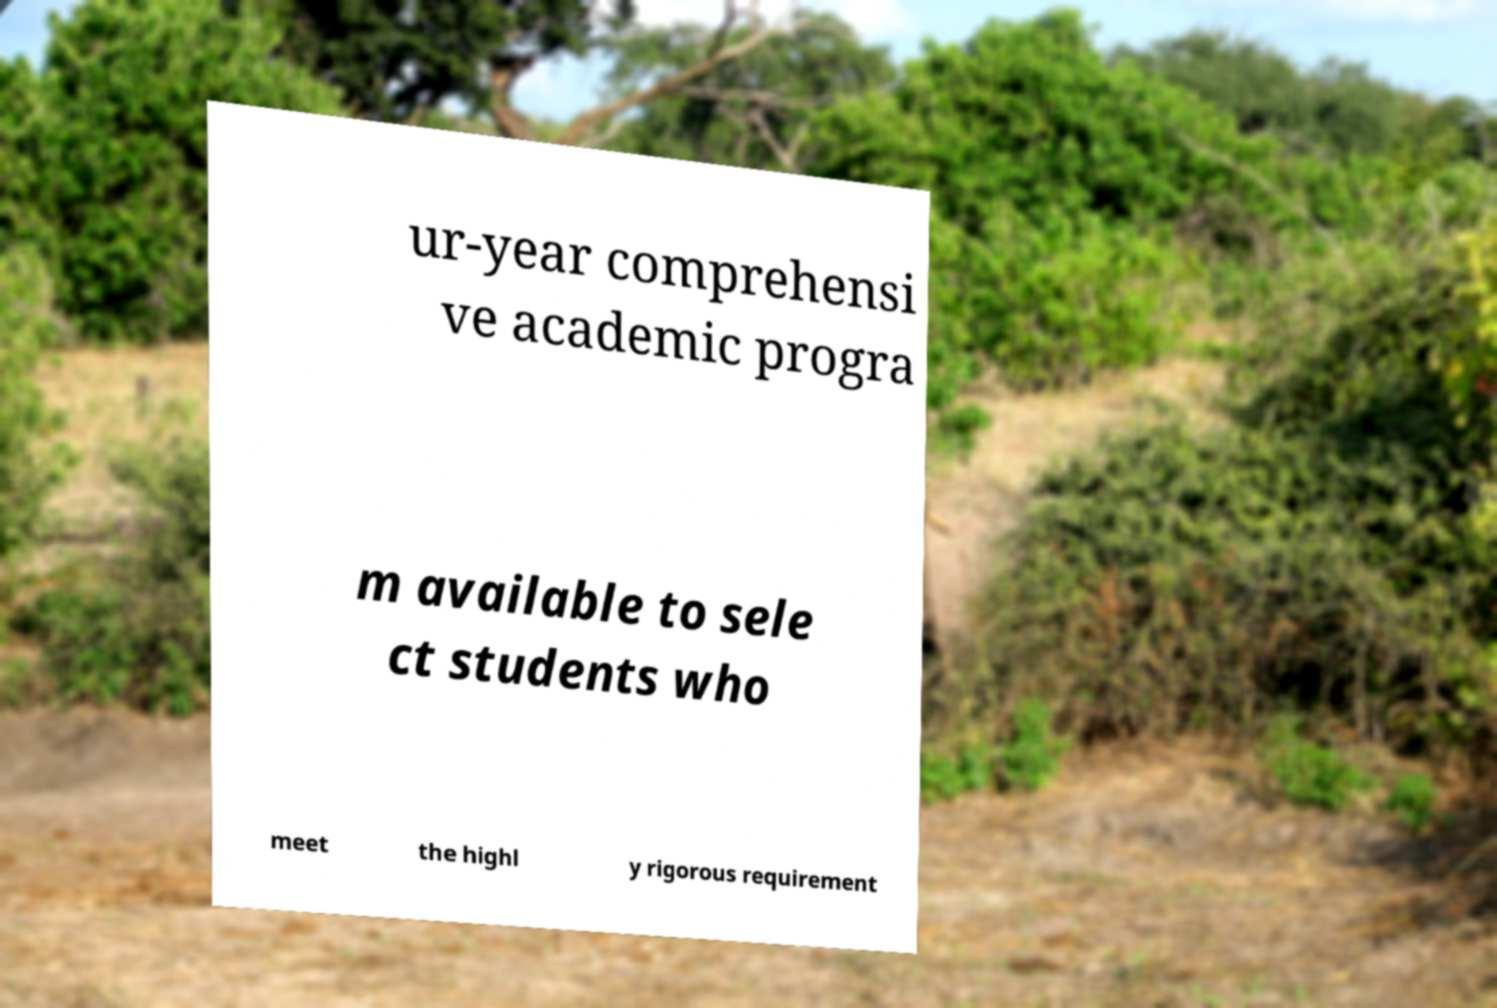Can you accurately transcribe the text from the provided image for me? ur-year comprehensi ve academic progra m available to sele ct students who meet the highl y rigorous requirement 